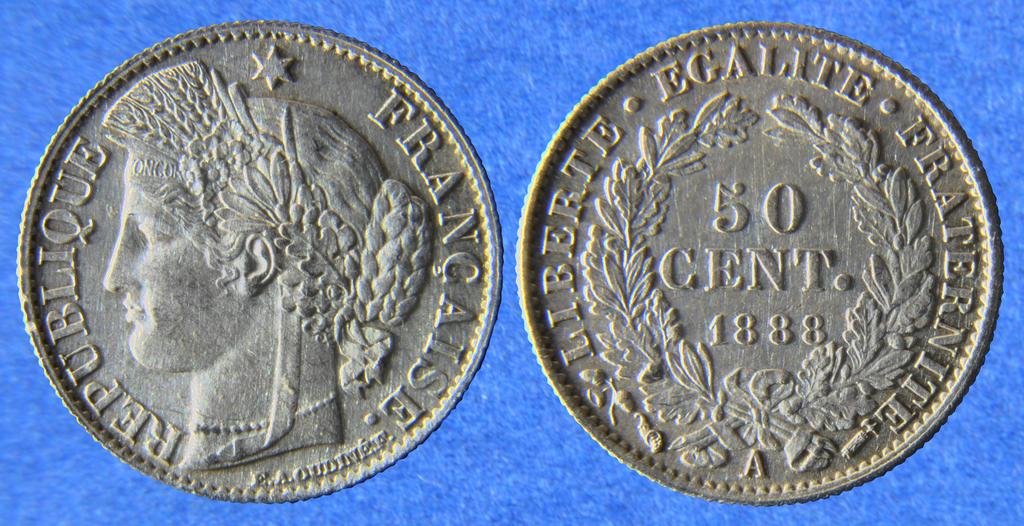How much is this coin worth?
Offer a terse response. 50 cent. How much is this worth?
Provide a succinct answer. 50 cent. 